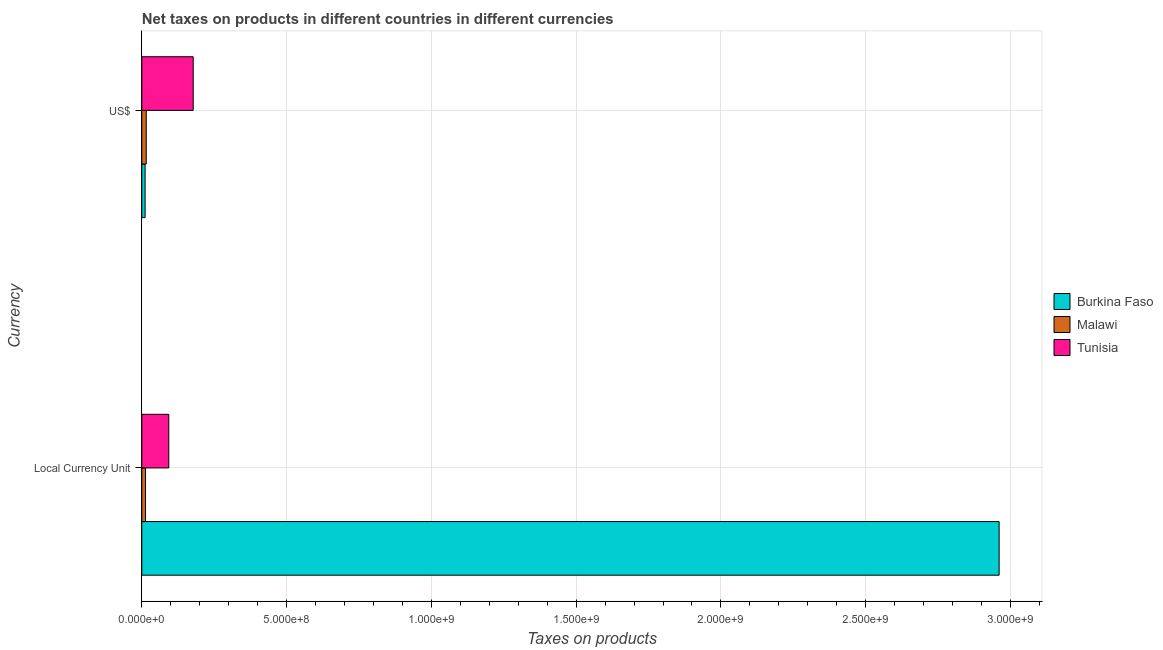Are the number of bars on each tick of the Y-axis equal?
Make the answer very short. Yes. How many bars are there on the 2nd tick from the top?
Keep it short and to the point. 3. What is the label of the 1st group of bars from the top?
Offer a terse response. US$. What is the net taxes in us$ in Malawi?
Offer a terse response. 1.54e+07. Across all countries, what is the maximum net taxes in constant 2005 us$?
Your answer should be very brief. 2.96e+09. Across all countries, what is the minimum net taxes in constant 2005 us$?
Provide a short and direct response. 1.28e+07. In which country was the net taxes in constant 2005 us$ maximum?
Provide a succinct answer. Burkina Faso. In which country was the net taxes in constant 2005 us$ minimum?
Give a very brief answer. Malawi. What is the total net taxes in constant 2005 us$ in the graph?
Make the answer very short. 3.07e+09. What is the difference between the net taxes in constant 2005 us$ in Burkina Faso and that in Tunisia?
Ensure brevity in your answer.  2.87e+09. What is the difference between the net taxes in constant 2005 us$ in Tunisia and the net taxes in us$ in Burkina Faso?
Provide a succinct answer. 8.18e+07. What is the average net taxes in us$ per country?
Offer a terse response. 6.81e+07. What is the difference between the net taxes in constant 2005 us$ and net taxes in us$ in Burkina Faso?
Give a very brief answer. 2.95e+09. What is the ratio of the net taxes in constant 2005 us$ in Tunisia to that in Malawi?
Your response must be concise. 7.28. Is the net taxes in constant 2005 us$ in Tunisia less than that in Burkina Faso?
Offer a terse response. Yes. In how many countries, is the net taxes in constant 2005 us$ greater than the average net taxes in constant 2005 us$ taken over all countries?
Keep it short and to the point. 1. What does the 3rd bar from the top in Local Currency Unit represents?
Ensure brevity in your answer.  Burkina Faso. What does the 3rd bar from the bottom in US$ represents?
Keep it short and to the point. Tunisia. How many countries are there in the graph?
Offer a very short reply. 3. What is the difference between two consecutive major ticks on the X-axis?
Your response must be concise. 5.00e+08. Where does the legend appear in the graph?
Your answer should be very brief. Center right. What is the title of the graph?
Your response must be concise. Net taxes on products in different countries in different currencies. What is the label or title of the X-axis?
Your answer should be compact. Taxes on products. What is the label or title of the Y-axis?
Your response must be concise. Currency. What is the Taxes on products in Burkina Faso in Local Currency Unit?
Your answer should be very brief. 2.96e+09. What is the Taxes on products of Malawi in Local Currency Unit?
Make the answer very short. 1.28e+07. What is the Taxes on products in Tunisia in Local Currency Unit?
Your answer should be very brief. 9.32e+07. What is the Taxes on products of Burkina Faso in US$?
Make the answer very short. 1.14e+07. What is the Taxes on products in Malawi in US$?
Give a very brief answer. 1.54e+07. What is the Taxes on products in Tunisia in US$?
Your answer should be compact. 1.78e+08. Across all Currency, what is the maximum Taxes on products in Burkina Faso?
Keep it short and to the point. 2.96e+09. Across all Currency, what is the maximum Taxes on products of Malawi?
Ensure brevity in your answer.  1.54e+07. Across all Currency, what is the maximum Taxes on products of Tunisia?
Make the answer very short. 1.78e+08. Across all Currency, what is the minimum Taxes on products in Burkina Faso?
Provide a short and direct response. 1.14e+07. Across all Currency, what is the minimum Taxes on products in Malawi?
Offer a terse response. 1.28e+07. Across all Currency, what is the minimum Taxes on products of Tunisia?
Provide a succinct answer. 9.32e+07. What is the total Taxes on products in Burkina Faso in the graph?
Offer a very short reply. 2.97e+09. What is the total Taxes on products of Malawi in the graph?
Your answer should be compact. 2.82e+07. What is the total Taxes on products in Tunisia in the graph?
Offer a terse response. 2.71e+08. What is the difference between the Taxes on products of Burkina Faso in Local Currency Unit and that in US$?
Your answer should be compact. 2.95e+09. What is the difference between the Taxes on products in Malawi in Local Currency Unit and that in US$?
Your answer should be very brief. -2.56e+06. What is the difference between the Taxes on products of Tunisia in Local Currency Unit and that in US$?
Make the answer very short. -8.43e+07. What is the difference between the Taxes on products of Burkina Faso in Local Currency Unit and the Taxes on products of Malawi in US$?
Provide a succinct answer. 2.95e+09. What is the difference between the Taxes on products of Burkina Faso in Local Currency Unit and the Taxes on products of Tunisia in US$?
Provide a short and direct response. 2.78e+09. What is the difference between the Taxes on products in Malawi in Local Currency Unit and the Taxes on products in Tunisia in US$?
Offer a very short reply. -1.65e+08. What is the average Taxes on products of Burkina Faso per Currency?
Your response must be concise. 1.49e+09. What is the average Taxes on products in Malawi per Currency?
Keep it short and to the point. 1.41e+07. What is the average Taxes on products in Tunisia per Currency?
Offer a very short reply. 1.35e+08. What is the difference between the Taxes on products in Burkina Faso and Taxes on products in Malawi in Local Currency Unit?
Provide a short and direct response. 2.95e+09. What is the difference between the Taxes on products in Burkina Faso and Taxes on products in Tunisia in Local Currency Unit?
Provide a short and direct response. 2.87e+09. What is the difference between the Taxes on products of Malawi and Taxes on products of Tunisia in Local Currency Unit?
Give a very brief answer. -8.04e+07. What is the difference between the Taxes on products in Burkina Faso and Taxes on products in Malawi in US$?
Offer a very short reply. -3.97e+06. What is the difference between the Taxes on products in Burkina Faso and Taxes on products in Tunisia in US$?
Offer a terse response. -1.66e+08. What is the difference between the Taxes on products in Malawi and Taxes on products in Tunisia in US$?
Keep it short and to the point. -1.62e+08. What is the ratio of the Taxes on products in Burkina Faso in Local Currency Unit to that in US$?
Provide a succinct answer. 259.96. What is the ratio of the Taxes on products in Malawi in Local Currency Unit to that in US$?
Make the answer very short. 0.83. What is the ratio of the Taxes on products of Tunisia in Local Currency Unit to that in US$?
Ensure brevity in your answer.  0.53. What is the difference between the highest and the second highest Taxes on products of Burkina Faso?
Your answer should be very brief. 2.95e+09. What is the difference between the highest and the second highest Taxes on products in Malawi?
Give a very brief answer. 2.56e+06. What is the difference between the highest and the second highest Taxes on products in Tunisia?
Your response must be concise. 8.43e+07. What is the difference between the highest and the lowest Taxes on products in Burkina Faso?
Offer a very short reply. 2.95e+09. What is the difference between the highest and the lowest Taxes on products of Malawi?
Provide a succinct answer. 2.56e+06. What is the difference between the highest and the lowest Taxes on products in Tunisia?
Ensure brevity in your answer.  8.43e+07. 